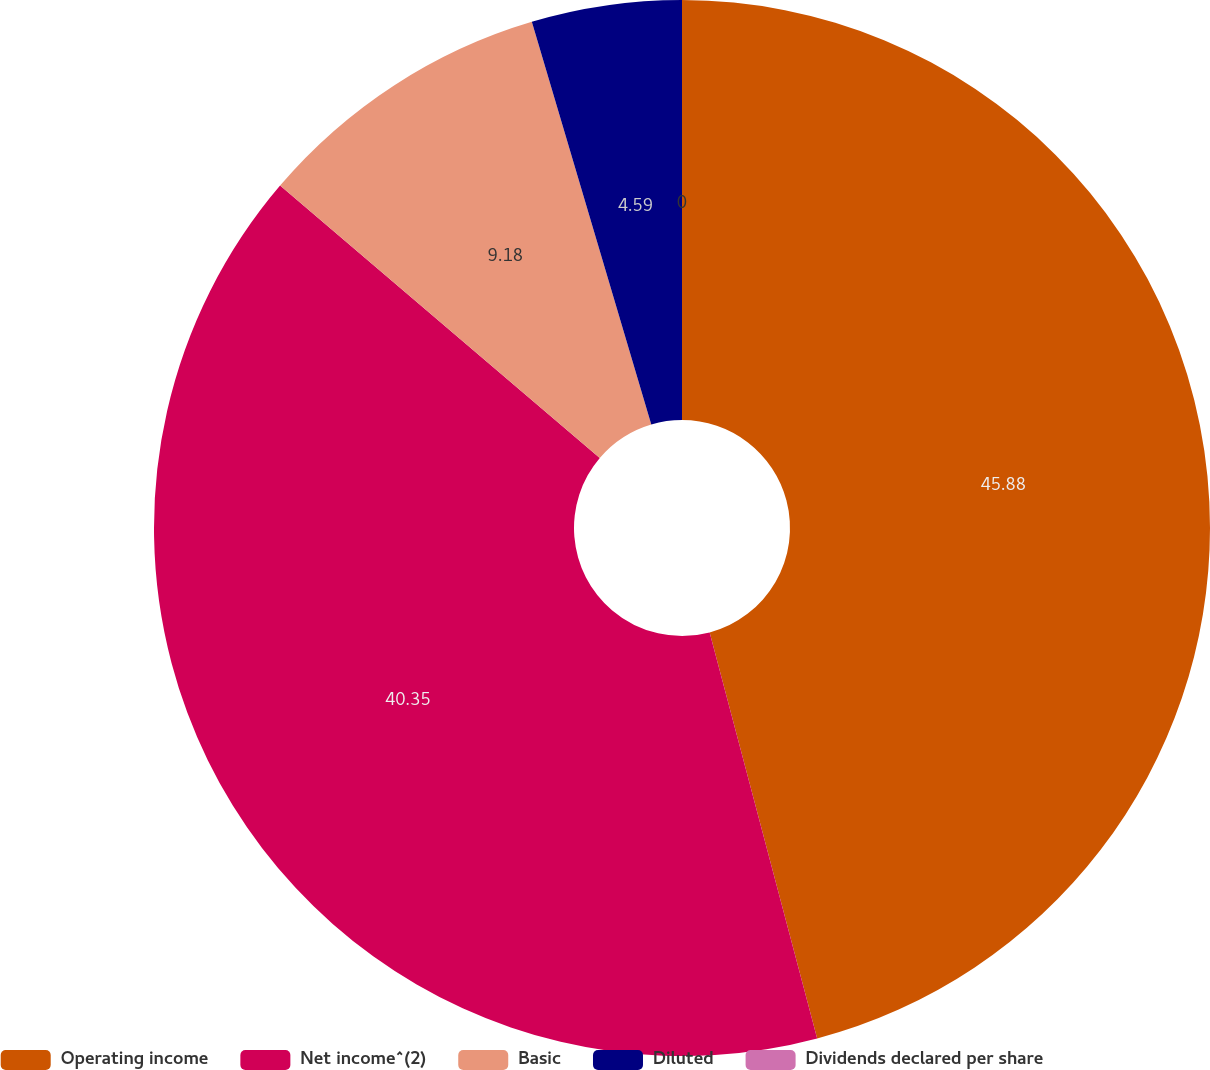<chart> <loc_0><loc_0><loc_500><loc_500><pie_chart><fcel>Operating income<fcel>Net income^(2)<fcel>Basic<fcel>Diluted<fcel>Dividends declared per share<nl><fcel>45.88%<fcel>40.35%<fcel>9.18%<fcel>4.59%<fcel>0.0%<nl></chart> 